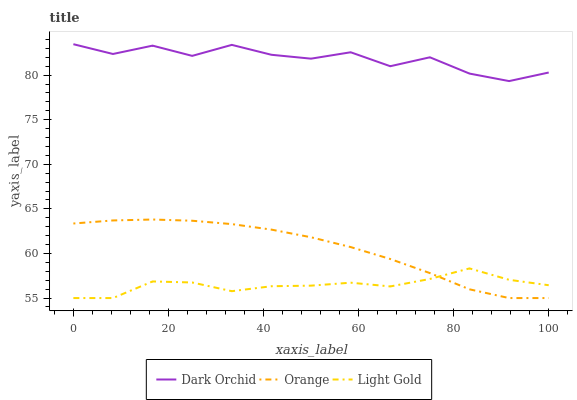Does Light Gold have the minimum area under the curve?
Answer yes or no. Yes. Does Dark Orchid have the maximum area under the curve?
Answer yes or no. Yes. Does Dark Orchid have the minimum area under the curve?
Answer yes or no. No. Does Light Gold have the maximum area under the curve?
Answer yes or no. No. Is Orange the smoothest?
Answer yes or no. Yes. Is Dark Orchid the roughest?
Answer yes or no. Yes. Is Light Gold the smoothest?
Answer yes or no. No. Is Light Gold the roughest?
Answer yes or no. No. Does Orange have the lowest value?
Answer yes or no. Yes. Does Dark Orchid have the lowest value?
Answer yes or no. No. Does Dark Orchid have the highest value?
Answer yes or no. Yes. Does Light Gold have the highest value?
Answer yes or no. No. Is Light Gold less than Dark Orchid?
Answer yes or no. Yes. Is Dark Orchid greater than Orange?
Answer yes or no. Yes. Does Light Gold intersect Orange?
Answer yes or no. Yes. Is Light Gold less than Orange?
Answer yes or no. No. Is Light Gold greater than Orange?
Answer yes or no. No. Does Light Gold intersect Dark Orchid?
Answer yes or no. No. 